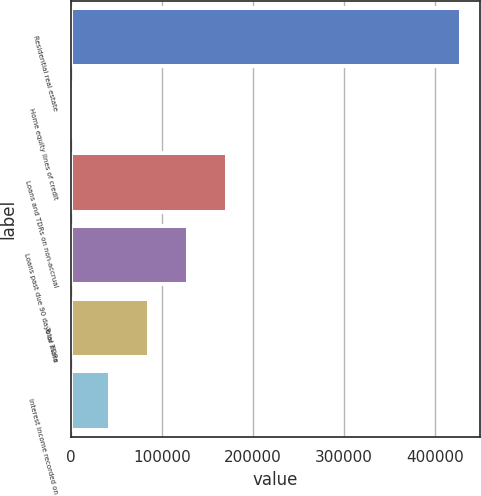Convert chart to OTSL. <chart><loc_0><loc_0><loc_500><loc_500><bar_chart><fcel>Residential real estate<fcel>Home equity lines of credit<fcel>Loans and TDRs on non-accrual<fcel>Loans past due 90 days or more<fcel>Total TDRs<fcel>Interest income recorded on<nl><fcel>428568<fcel>174<fcel>171532<fcel>128692<fcel>85852.8<fcel>43013.4<nl></chart> 